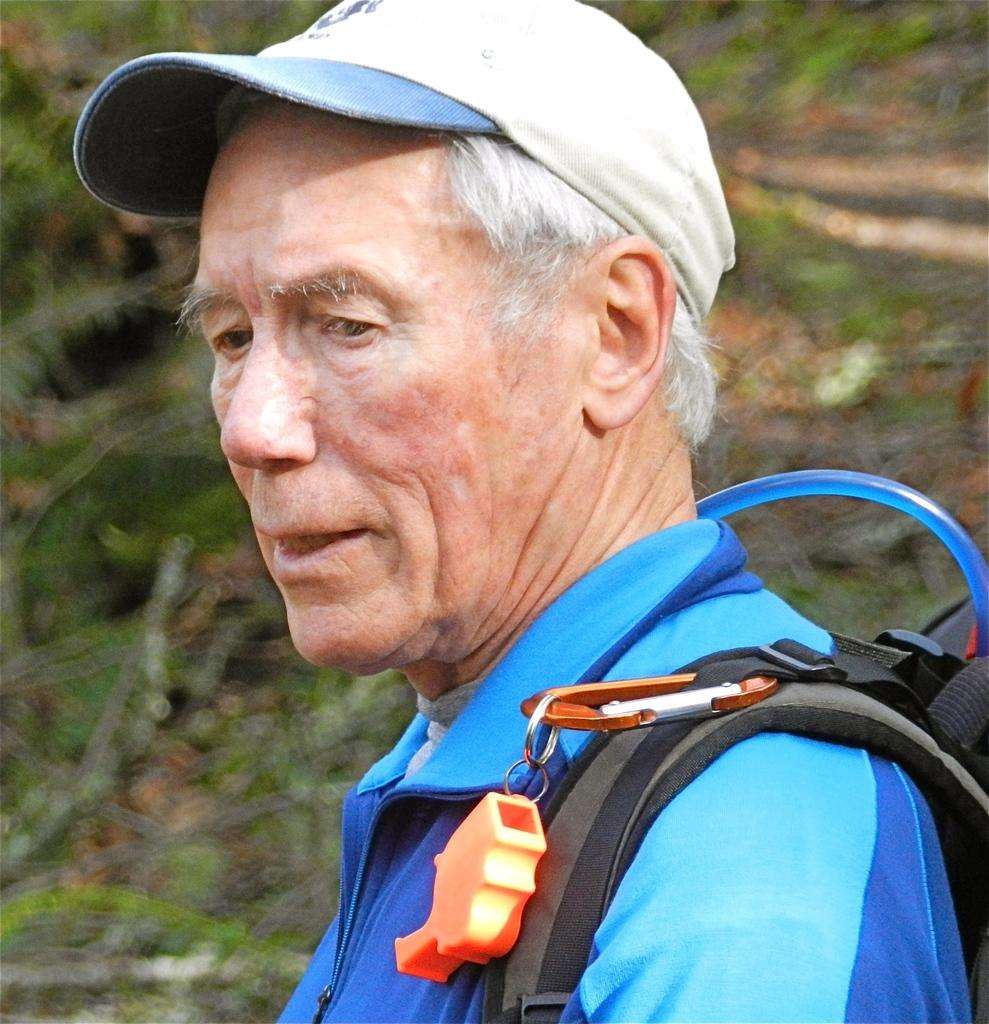What is the main subject of the image? There is a person in the image. Can you describe the background of the image? The background of the image is blurry. What type of boat can be seen in the image? There is no boat present in the image; it only features a person and a blurry background. 